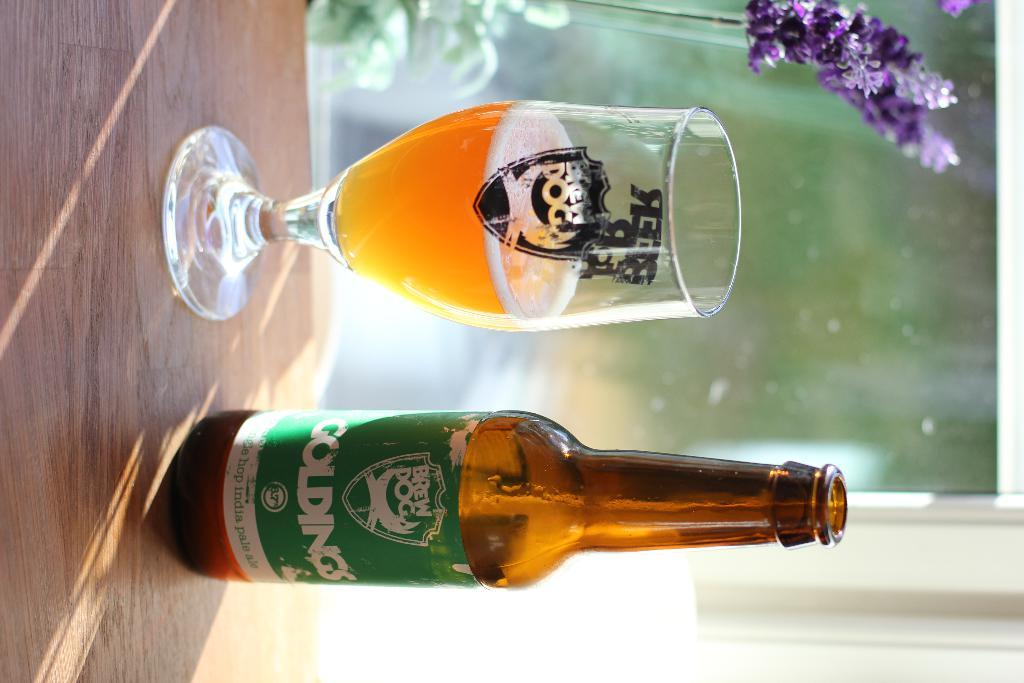What is present on the table in the image? There is a bottle and a glass on the table in the image. What is inside the glass? There is a liquid in the glass. What color is the flower in the top right corner of the image? The flower in the top right corner of the image is violet. How many clover leaves can be seen in the image? There are no clover leaves present in the image. What reward is being given to the horse in the image? There is no horse present in the image, so no reward can be given. 